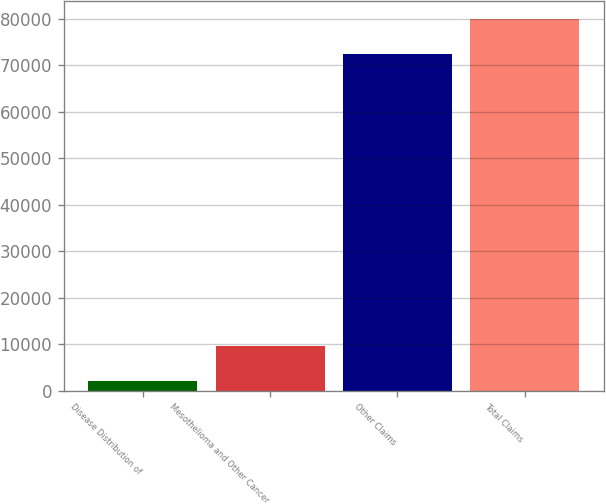Convert chart to OTSL. <chart><loc_0><loc_0><loc_500><loc_500><bar_chart><fcel>Disease Distribution of<fcel>Mesothelioma and Other Cancer<fcel>Other Claims<fcel>Total Claims<nl><fcel>2005<fcel>9502.3<fcel>72374<fcel>79871.3<nl></chart> 